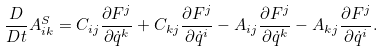<formula> <loc_0><loc_0><loc_500><loc_500>\frac { D } { D t } A ^ { S } _ { i k } = C _ { i j } \frac { \partial F ^ { j } } { \partial \dot { q } ^ { k } } + C _ { k j } \frac { \partial F ^ { j } } { \partial \dot { q } ^ { i } } - A _ { i j } \frac { \partial F ^ { j } } { \partial \dot { q } ^ { k } } - A _ { k j } \frac { \partial F ^ { j } } { \partial \dot { q } ^ { i } } .</formula> 